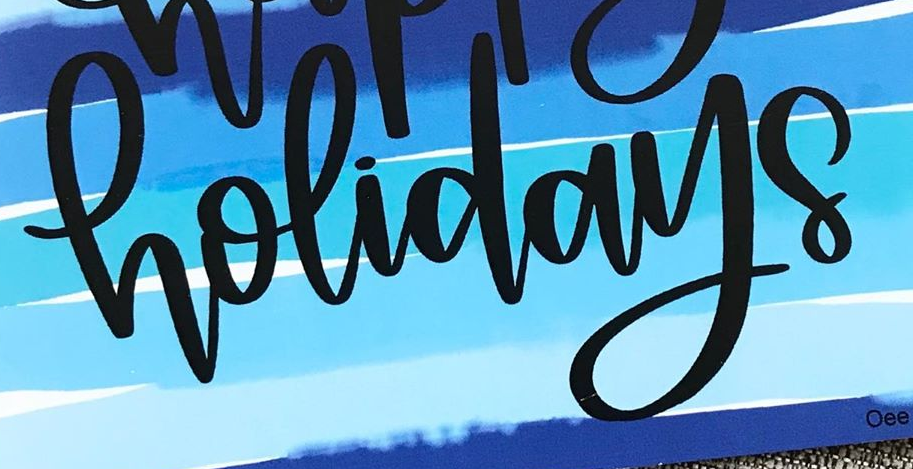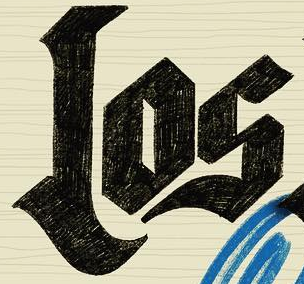What words can you see in these images in sequence, separated by a semicolon? holidays; Los 